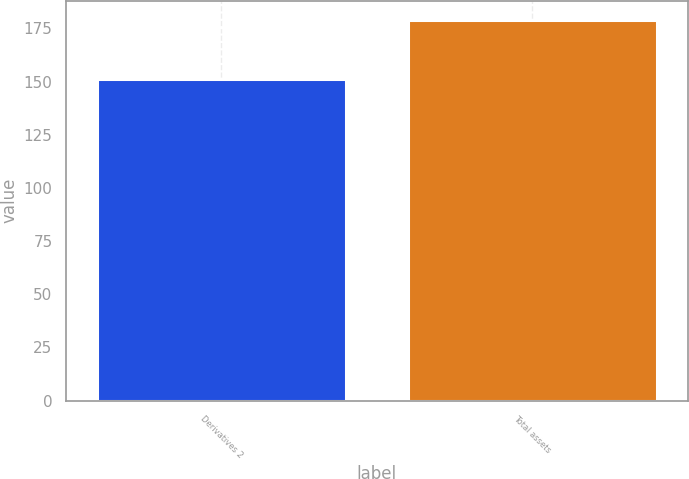<chart> <loc_0><loc_0><loc_500><loc_500><bar_chart><fcel>Derivatives 2<fcel>Total assets<nl><fcel>151<fcel>179<nl></chart> 